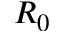<formula> <loc_0><loc_0><loc_500><loc_500>R _ { 0 }</formula> 